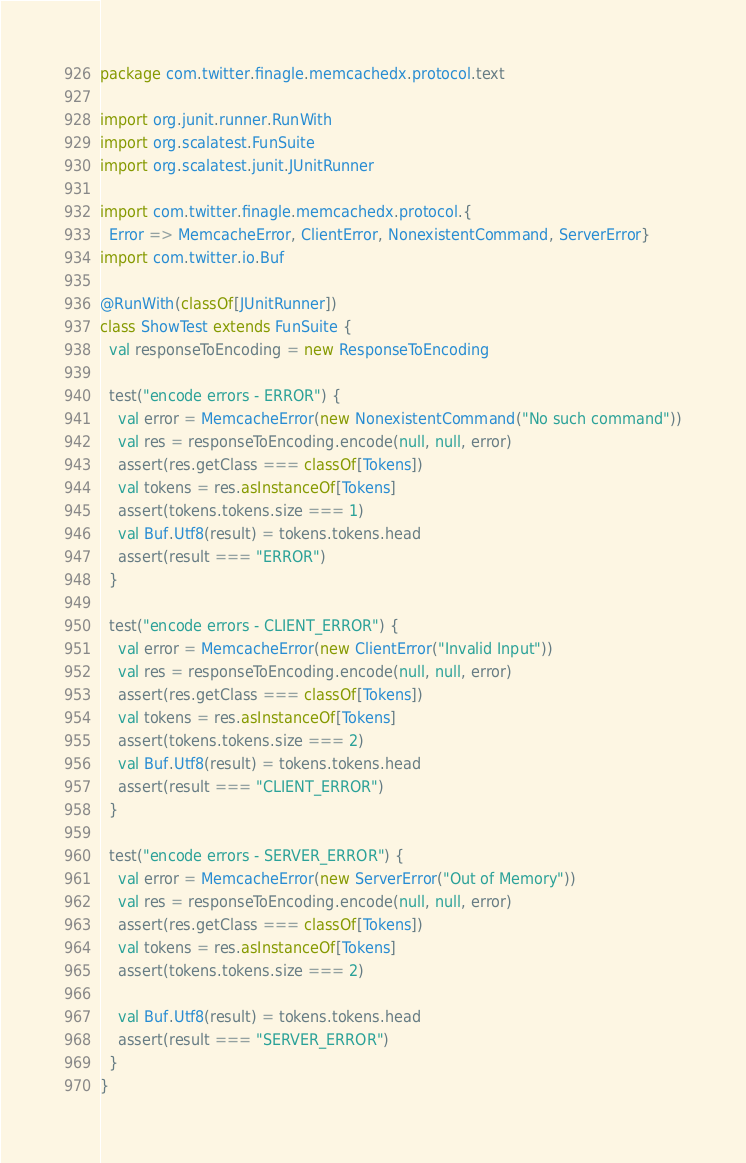<code> <loc_0><loc_0><loc_500><loc_500><_Scala_>package com.twitter.finagle.memcachedx.protocol.text

import org.junit.runner.RunWith
import org.scalatest.FunSuite
import org.scalatest.junit.JUnitRunner

import com.twitter.finagle.memcachedx.protocol.{
  Error => MemcacheError, ClientError, NonexistentCommand, ServerError}
import com.twitter.io.Buf

@RunWith(classOf[JUnitRunner])
class ShowTest extends FunSuite {
  val responseToEncoding = new ResponseToEncoding

  test("encode errors - ERROR") {
    val error = MemcacheError(new NonexistentCommand("No such command"))
    val res = responseToEncoding.encode(null, null, error)
    assert(res.getClass === classOf[Tokens])
    val tokens = res.asInstanceOf[Tokens]
    assert(tokens.tokens.size === 1)
    val Buf.Utf8(result) = tokens.tokens.head
    assert(result === "ERROR")
  }

  test("encode errors - CLIENT_ERROR") {
    val error = MemcacheError(new ClientError("Invalid Input"))
    val res = responseToEncoding.encode(null, null, error)
    assert(res.getClass === classOf[Tokens])
    val tokens = res.asInstanceOf[Tokens]
    assert(tokens.tokens.size === 2)
    val Buf.Utf8(result) = tokens.tokens.head
    assert(result === "CLIENT_ERROR")
  }

  test("encode errors - SERVER_ERROR") {
    val error = MemcacheError(new ServerError("Out of Memory"))
    val res = responseToEncoding.encode(null, null, error)
    assert(res.getClass === classOf[Tokens])
    val tokens = res.asInstanceOf[Tokens]
    assert(tokens.tokens.size === 2)

    val Buf.Utf8(result) = tokens.tokens.head
    assert(result === "SERVER_ERROR")
  }
}
</code> 